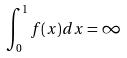<formula> <loc_0><loc_0><loc_500><loc_500>\int _ { 0 } ^ { 1 } f ( x ) d x = \infty</formula> 